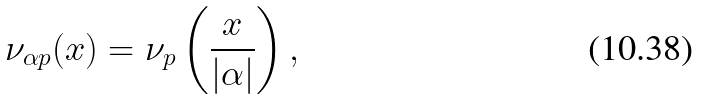<formula> <loc_0><loc_0><loc_500><loc_500>\nu _ { \alpha p } ( x ) = \nu _ { p } \left ( \frac { x } { | \alpha | } \right ) ,</formula> 